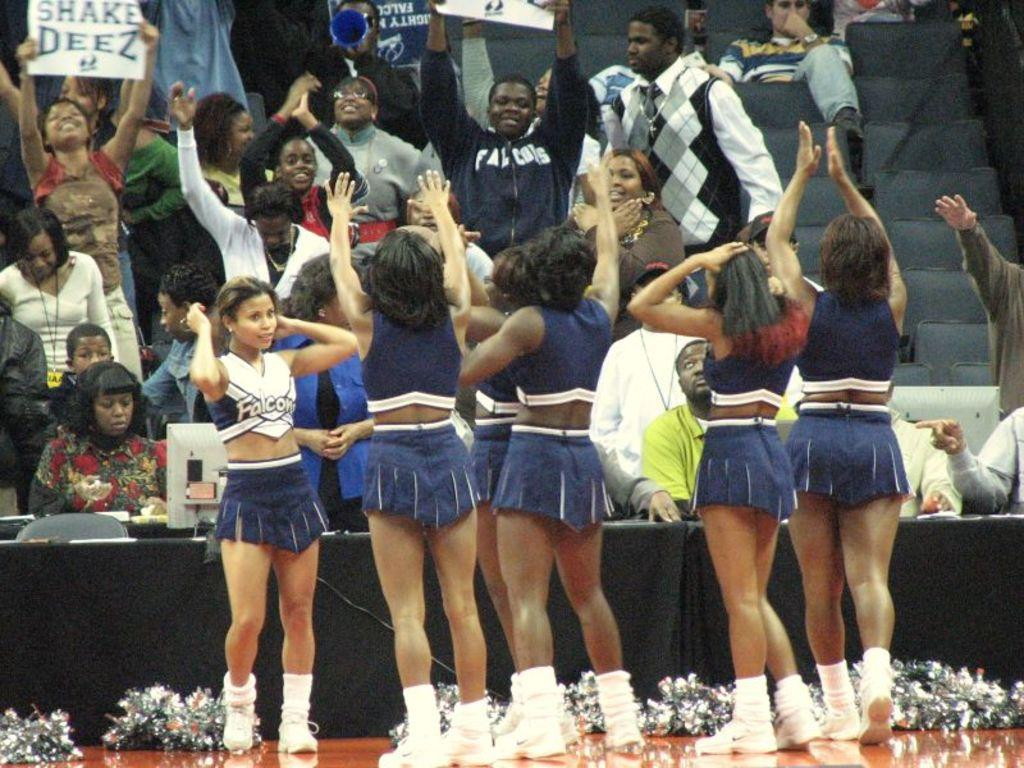<image>
Present a compact description of the photo's key features. A group of cheerleaders perform before a crowd at a Falcons game. 